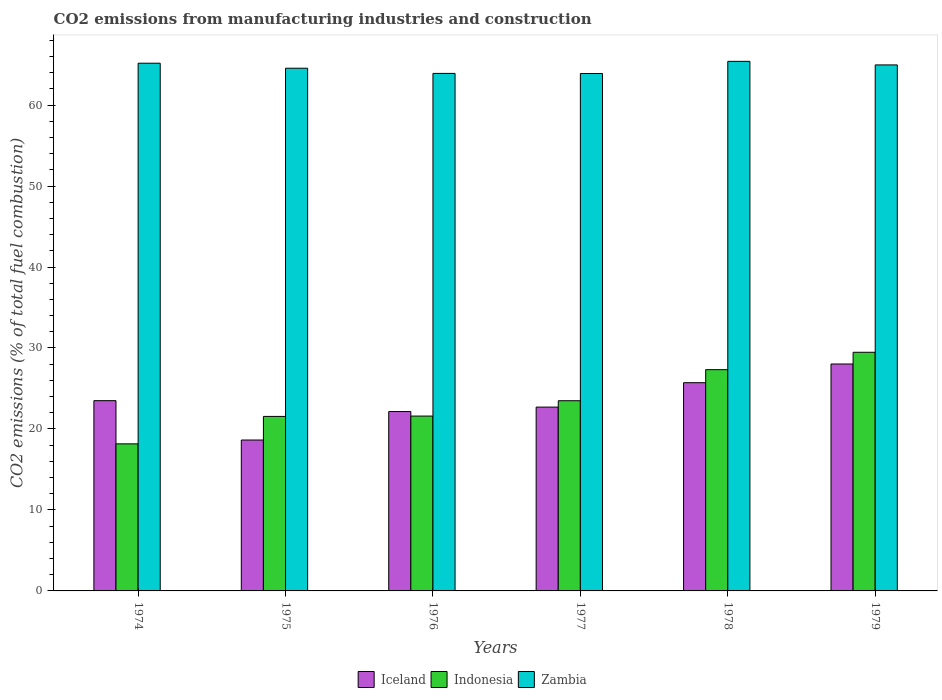How many different coloured bars are there?
Provide a succinct answer. 3. How many groups of bars are there?
Your answer should be very brief. 6. How many bars are there on the 5th tick from the left?
Offer a terse response. 3. How many bars are there on the 1st tick from the right?
Provide a succinct answer. 3. What is the label of the 1st group of bars from the left?
Give a very brief answer. 1974. In how many cases, is the number of bars for a given year not equal to the number of legend labels?
Ensure brevity in your answer.  0. What is the amount of CO2 emitted in Zambia in 1978?
Offer a very short reply. 65.4. Across all years, what is the maximum amount of CO2 emitted in Zambia?
Offer a terse response. 65.4. Across all years, what is the minimum amount of CO2 emitted in Zambia?
Provide a short and direct response. 63.9. In which year was the amount of CO2 emitted in Indonesia maximum?
Keep it short and to the point. 1979. In which year was the amount of CO2 emitted in Iceland minimum?
Your answer should be very brief. 1975. What is the total amount of CO2 emitted in Indonesia in the graph?
Your answer should be very brief. 141.58. What is the difference between the amount of CO2 emitted in Indonesia in 1976 and that in 1979?
Keep it short and to the point. -7.88. What is the difference between the amount of CO2 emitted in Iceland in 1975 and the amount of CO2 emitted in Indonesia in 1974?
Offer a terse response. 0.47. What is the average amount of CO2 emitted in Indonesia per year?
Keep it short and to the point. 23.6. In the year 1974, what is the difference between the amount of CO2 emitted in Zambia and amount of CO2 emitted in Indonesia?
Offer a very short reply. 47. In how many years, is the amount of CO2 emitted in Indonesia greater than 56 %?
Offer a very short reply. 0. What is the ratio of the amount of CO2 emitted in Indonesia in 1975 to that in 1977?
Provide a short and direct response. 0.92. Is the difference between the amount of CO2 emitted in Zambia in 1975 and 1976 greater than the difference between the amount of CO2 emitted in Indonesia in 1975 and 1976?
Your answer should be compact. Yes. What is the difference between the highest and the second highest amount of CO2 emitted in Zambia?
Offer a terse response. 0.23. What is the difference between the highest and the lowest amount of CO2 emitted in Zambia?
Offer a terse response. 1.5. In how many years, is the amount of CO2 emitted in Iceland greater than the average amount of CO2 emitted in Iceland taken over all years?
Offer a terse response. 3. Is the sum of the amount of CO2 emitted in Iceland in 1974 and 1979 greater than the maximum amount of CO2 emitted in Zambia across all years?
Your answer should be compact. No. What does the 1st bar from the left in 1977 represents?
Your answer should be very brief. Iceland. How many years are there in the graph?
Offer a terse response. 6. Are the values on the major ticks of Y-axis written in scientific E-notation?
Provide a short and direct response. No. Does the graph contain any zero values?
Provide a succinct answer. No. How many legend labels are there?
Keep it short and to the point. 3. What is the title of the graph?
Keep it short and to the point. CO2 emissions from manufacturing industries and construction. Does "Chile" appear as one of the legend labels in the graph?
Ensure brevity in your answer.  No. What is the label or title of the X-axis?
Your answer should be very brief. Years. What is the label or title of the Y-axis?
Your response must be concise. CO2 emissions (% of total fuel combustion). What is the CO2 emissions (% of total fuel combustion) of Iceland in 1974?
Your answer should be compact. 23.49. What is the CO2 emissions (% of total fuel combustion) of Indonesia in 1974?
Make the answer very short. 18.16. What is the CO2 emissions (% of total fuel combustion) in Zambia in 1974?
Ensure brevity in your answer.  65.17. What is the CO2 emissions (% of total fuel combustion) of Iceland in 1975?
Your answer should be compact. 18.63. What is the CO2 emissions (% of total fuel combustion) of Indonesia in 1975?
Provide a succinct answer. 21.55. What is the CO2 emissions (% of total fuel combustion) in Zambia in 1975?
Make the answer very short. 64.55. What is the CO2 emissions (% of total fuel combustion) of Iceland in 1976?
Provide a short and direct response. 22.15. What is the CO2 emissions (% of total fuel combustion) of Indonesia in 1976?
Give a very brief answer. 21.59. What is the CO2 emissions (% of total fuel combustion) in Zambia in 1976?
Provide a short and direct response. 63.91. What is the CO2 emissions (% of total fuel combustion) in Iceland in 1977?
Make the answer very short. 22.7. What is the CO2 emissions (% of total fuel combustion) of Indonesia in 1977?
Your answer should be compact. 23.49. What is the CO2 emissions (% of total fuel combustion) of Zambia in 1977?
Make the answer very short. 63.9. What is the CO2 emissions (% of total fuel combustion) in Iceland in 1978?
Provide a short and direct response. 25.71. What is the CO2 emissions (% of total fuel combustion) in Indonesia in 1978?
Your answer should be compact. 27.32. What is the CO2 emissions (% of total fuel combustion) in Zambia in 1978?
Your response must be concise. 65.4. What is the CO2 emissions (% of total fuel combustion) of Iceland in 1979?
Provide a short and direct response. 28.02. What is the CO2 emissions (% of total fuel combustion) of Indonesia in 1979?
Keep it short and to the point. 29.47. What is the CO2 emissions (% of total fuel combustion) in Zambia in 1979?
Provide a short and direct response. 64.95. Across all years, what is the maximum CO2 emissions (% of total fuel combustion) of Iceland?
Your response must be concise. 28.02. Across all years, what is the maximum CO2 emissions (% of total fuel combustion) in Indonesia?
Offer a terse response. 29.47. Across all years, what is the maximum CO2 emissions (% of total fuel combustion) in Zambia?
Your answer should be very brief. 65.4. Across all years, what is the minimum CO2 emissions (% of total fuel combustion) in Iceland?
Offer a terse response. 18.63. Across all years, what is the minimum CO2 emissions (% of total fuel combustion) of Indonesia?
Ensure brevity in your answer.  18.16. Across all years, what is the minimum CO2 emissions (% of total fuel combustion) in Zambia?
Provide a short and direct response. 63.9. What is the total CO2 emissions (% of total fuel combustion) of Iceland in the graph?
Provide a succinct answer. 140.72. What is the total CO2 emissions (% of total fuel combustion) of Indonesia in the graph?
Your response must be concise. 141.58. What is the total CO2 emissions (% of total fuel combustion) in Zambia in the graph?
Provide a succinct answer. 387.87. What is the difference between the CO2 emissions (% of total fuel combustion) in Iceland in 1974 and that in 1975?
Offer a very short reply. 4.86. What is the difference between the CO2 emissions (% of total fuel combustion) in Indonesia in 1974 and that in 1975?
Your answer should be very brief. -3.39. What is the difference between the CO2 emissions (% of total fuel combustion) in Zambia in 1974 and that in 1975?
Give a very brief answer. 0.62. What is the difference between the CO2 emissions (% of total fuel combustion) in Iceland in 1974 and that in 1976?
Your answer should be very brief. 1.34. What is the difference between the CO2 emissions (% of total fuel combustion) of Indonesia in 1974 and that in 1976?
Your answer should be compact. -3.43. What is the difference between the CO2 emissions (% of total fuel combustion) in Zambia in 1974 and that in 1976?
Ensure brevity in your answer.  1.26. What is the difference between the CO2 emissions (% of total fuel combustion) of Iceland in 1974 and that in 1977?
Give a very brief answer. 0.79. What is the difference between the CO2 emissions (% of total fuel combustion) in Indonesia in 1974 and that in 1977?
Give a very brief answer. -5.33. What is the difference between the CO2 emissions (% of total fuel combustion) of Zambia in 1974 and that in 1977?
Make the answer very short. 1.27. What is the difference between the CO2 emissions (% of total fuel combustion) of Iceland in 1974 and that in 1978?
Offer a terse response. -2.22. What is the difference between the CO2 emissions (% of total fuel combustion) of Indonesia in 1974 and that in 1978?
Offer a very short reply. -9.16. What is the difference between the CO2 emissions (% of total fuel combustion) of Zambia in 1974 and that in 1978?
Keep it short and to the point. -0.23. What is the difference between the CO2 emissions (% of total fuel combustion) in Iceland in 1974 and that in 1979?
Keep it short and to the point. -4.53. What is the difference between the CO2 emissions (% of total fuel combustion) of Indonesia in 1974 and that in 1979?
Your answer should be compact. -11.31. What is the difference between the CO2 emissions (% of total fuel combustion) in Zambia in 1974 and that in 1979?
Your answer should be compact. 0.21. What is the difference between the CO2 emissions (% of total fuel combustion) of Iceland in 1975 and that in 1976?
Your answer should be very brief. -3.52. What is the difference between the CO2 emissions (% of total fuel combustion) of Indonesia in 1975 and that in 1976?
Provide a short and direct response. -0.04. What is the difference between the CO2 emissions (% of total fuel combustion) of Zambia in 1975 and that in 1976?
Your response must be concise. 0.64. What is the difference between the CO2 emissions (% of total fuel combustion) of Iceland in 1975 and that in 1977?
Provide a succinct answer. -4.07. What is the difference between the CO2 emissions (% of total fuel combustion) of Indonesia in 1975 and that in 1977?
Ensure brevity in your answer.  -1.94. What is the difference between the CO2 emissions (% of total fuel combustion) of Zambia in 1975 and that in 1977?
Offer a very short reply. 0.65. What is the difference between the CO2 emissions (% of total fuel combustion) in Iceland in 1975 and that in 1978?
Give a very brief answer. -7.08. What is the difference between the CO2 emissions (% of total fuel combustion) of Indonesia in 1975 and that in 1978?
Give a very brief answer. -5.77. What is the difference between the CO2 emissions (% of total fuel combustion) of Zambia in 1975 and that in 1978?
Ensure brevity in your answer.  -0.85. What is the difference between the CO2 emissions (% of total fuel combustion) of Iceland in 1975 and that in 1979?
Ensure brevity in your answer.  -9.39. What is the difference between the CO2 emissions (% of total fuel combustion) in Indonesia in 1975 and that in 1979?
Keep it short and to the point. -7.92. What is the difference between the CO2 emissions (% of total fuel combustion) in Zambia in 1975 and that in 1979?
Make the answer very short. -0.41. What is the difference between the CO2 emissions (% of total fuel combustion) of Iceland in 1976 and that in 1977?
Offer a very short reply. -0.55. What is the difference between the CO2 emissions (% of total fuel combustion) of Indonesia in 1976 and that in 1977?
Provide a succinct answer. -1.9. What is the difference between the CO2 emissions (% of total fuel combustion) of Zambia in 1976 and that in 1977?
Offer a terse response. 0.01. What is the difference between the CO2 emissions (% of total fuel combustion) of Iceland in 1976 and that in 1978?
Offer a terse response. -3.56. What is the difference between the CO2 emissions (% of total fuel combustion) in Indonesia in 1976 and that in 1978?
Offer a terse response. -5.73. What is the difference between the CO2 emissions (% of total fuel combustion) in Zambia in 1976 and that in 1978?
Your answer should be very brief. -1.49. What is the difference between the CO2 emissions (% of total fuel combustion) of Iceland in 1976 and that in 1979?
Your answer should be very brief. -5.87. What is the difference between the CO2 emissions (% of total fuel combustion) of Indonesia in 1976 and that in 1979?
Make the answer very short. -7.88. What is the difference between the CO2 emissions (% of total fuel combustion) of Zambia in 1976 and that in 1979?
Offer a very short reply. -1.05. What is the difference between the CO2 emissions (% of total fuel combustion) of Iceland in 1977 and that in 1978?
Offer a very short reply. -3.01. What is the difference between the CO2 emissions (% of total fuel combustion) in Indonesia in 1977 and that in 1978?
Your response must be concise. -3.84. What is the difference between the CO2 emissions (% of total fuel combustion) in Zambia in 1977 and that in 1978?
Offer a very short reply. -1.5. What is the difference between the CO2 emissions (% of total fuel combustion) in Iceland in 1977 and that in 1979?
Offer a terse response. -5.32. What is the difference between the CO2 emissions (% of total fuel combustion) of Indonesia in 1977 and that in 1979?
Your response must be concise. -5.98. What is the difference between the CO2 emissions (% of total fuel combustion) in Zambia in 1977 and that in 1979?
Your response must be concise. -1.06. What is the difference between the CO2 emissions (% of total fuel combustion) of Iceland in 1978 and that in 1979?
Your response must be concise. -2.31. What is the difference between the CO2 emissions (% of total fuel combustion) in Indonesia in 1978 and that in 1979?
Your answer should be compact. -2.15. What is the difference between the CO2 emissions (% of total fuel combustion) in Zambia in 1978 and that in 1979?
Offer a very short reply. 0.44. What is the difference between the CO2 emissions (% of total fuel combustion) in Iceland in 1974 and the CO2 emissions (% of total fuel combustion) in Indonesia in 1975?
Ensure brevity in your answer.  1.95. What is the difference between the CO2 emissions (% of total fuel combustion) of Iceland in 1974 and the CO2 emissions (% of total fuel combustion) of Zambia in 1975?
Provide a succinct answer. -41.05. What is the difference between the CO2 emissions (% of total fuel combustion) in Indonesia in 1974 and the CO2 emissions (% of total fuel combustion) in Zambia in 1975?
Provide a succinct answer. -46.38. What is the difference between the CO2 emissions (% of total fuel combustion) in Iceland in 1974 and the CO2 emissions (% of total fuel combustion) in Indonesia in 1976?
Offer a terse response. 1.9. What is the difference between the CO2 emissions (% of total fuel combustion) of Iceland in 1974 and the CO2 emissions (% of total fuel combustion) of Zambia in 1976?
Offer a very short reply. -40.41. What is the difference between the CO2 emissions (% of total fuel combustion) of Indonesia in 1974 and the CO2 emissions (% of total fuel combustion) of Zambia in 1976?
Your answer should be compact. -45.75. What is the difference between the CO2 emissions (% of total fuel combustion) in Iceland in 1974 and the CO2 emissions (% of total fuel combustion) in Indonesia in 1977?
Provide a short and direct response. 0.01. What is the difference between the CO2 emissions (% of total fuel combustion) in Iceland in 1974 and the CO2 emissions (% of total fuel combustion) in Zambia in 1977?
Your answer should be compact. -40.4. What is the difference between the CO2 emissions (% of total fuel combustion) in Indonesia in 1974 and the CO2 emissions (% of total fuel combustion) in Zambia in 1977?
Keep it short and to the point. -45.73. What is the difference between the CO2 emissions (% of total fuel combustion) of Iceland in 1974 and the CO2 emissions (% of total fuel combustion) of Indonesia in 1978?
Give a very brief answer. -3.83. What is the difference between the CO2 emissions (% of total fuel combustion) in Iceland in 1974 and the CO2 emissions (% of total fuel combustion) in Zambia in 1978?
Give a very brief answer. -41.9. What is the difference between the CO2 emissions (% of total fuel combustion) of Indonesia in 1974 and the CO2 emissions (% of total fuel combustion) of Zambia in 1978?
Offer a very short reply. -47.23. What is the difference between the CO2 emissions (% of total fuel combustion) of Iceland in 1974 and the CO2 emissions (% of total fuel combustion) of Indonesia in 1979?
Ensure brevity in your answer.  -5.98. What is the difference between the CO2 emissions (% of total fuel combustion) of Iceland in 1974 and the CO2 emissions (% of total fuel combustion) of Zambia in 1979?
Give a very brief answer. -41.46. What is the difference between the CO2 emissions (% of total fuel combustion) of Indonesia in 1974 and the CO2 emissions (% of total fuel combustion) of Zambia in 1979?
Offer a very short reply. -46.79. What is the difference between the CO2 emissions (% of total fuel combustion) of Iceland in 1975 and the CO2 emissions (% of total fuel combustion) of Indonesia in 1976?
Provide a short and direct response. -2.96. What is the difference between the CO2 emissions (% of total fuel combustion) in Iceland in 1975 and the CO2 emissions (% of total fuel combustion) in Zambia in 1976?
Give a very brief answer. -45.27. What is the difference between the CO2 emissions (% of total fuel combustion) of Indonesia in 1975 and the CO2 emissions (% of total fuel combustion) of Zambia in 1976?
Provide a succinct answer. -42.36. What is the difference between the CO2 emissions (% of total fuel combustion) in Iceland in 1975 and the CO2 emissions (% of total fuel combustion) in Indonesia in 1977?
Give a very brief answer. -4.85. What is the difference between the CO2 emissions (% of total fuel combustion) in Iceland in 1975 and the CO2 emissions (% of total fuel combustion) in Zambia in 1977?
Offer a terse response. -45.26. What is the difference between the CO2 emissions (% of total fuel combustion) of Indonesia in 1975 and the CO2 emissions (% of total fuel combustion) of Zambia in 1977?
Provide a short and direct response. -42.35. What is the difference between the CO2 emissions (% of total fuel combustion) in Iceland in 1975 and the CO2 emissions (% of total fuel combustion) in Indonesia in 1978?
Your response must be concise. -8.69. What is the difference between the CO2 emissions (% of total fuel combustion) of Iceland in 1975 and the CO2 emissions (% of total fuel combustion) of Zambia in 1978?
Offer a very short reply. -46.76. What is the difference between the CO2 emissions (% of total fuel combustion) in Indonesia in 1975 and the CO2 emissions (% of total fuel combustion) in Zambia in 1978?
Make the answer very short. -43.85. What is the difference between the CO2 emissions (% of total fuel combustion) of Iceland in 1975 and the CO2 emissions (% of total fuel combustion) of Indonesia in 1979?
Your answer should be very brief. -10.84. What is the difference between the CO2 emissions (% of total fuel combustion) of Iceland in 1975 and the CO2 emissions (% of total fuel combustion) of Zambia in 1979?
Offer a terse response. -46.32. What is the difference between the CO2 emissions (% of total fuel combustion) of Indonesia in 1975 and the CO2 emissions (% of total fuel combustion) of Zambia in 1979?
Offer a very short reply. -43.41. What is the difference between the CO2 emissions (% of total fuel combustion) in Iceland in 1976 and the CO2 emissions (% of total fuel combustion) in Indonesia in 1977?
Provide a short and direct response. -1.34. What is the difference between the CO2 emissions (% of total fuel combustion) of Iceland in 1976 and the CO2 emissions (% of total fuel combustion) of Zambia in 1977?
Provide a short and direct response. -41.74. What is the difference between the CO2 emissions (% of total fuel combustion) of Indonesia in 1976 and the CO2 emissions (% of total fuel combustion) of Zambia in 1977?
Your answer should be very brief. -42.3. What is the difference between the CO2 emissions (% of total fuel combustion) of Iceland in 1976 and the CO2 emissions (% of total fuel combustion) of Indonesia in 1978?
Your answer should be very brief. -5.17. What is the difference between the CO2 emissions (% of total fuel combustion) in Iceland in 1976 and the CO2 emissions (% of total fuel combustion) in Zambia in 1978?
Keep it short and to the point. -43.24. What is the difference between the CO2 emissions (% of total fuel combustion) of Indonesia in 1976 and the CO2 emissions (% of total fuel combustion) of Zambia in 1978?
Provide a succinct answer. -43.8. What is the difference between the CO2 emissions (% of total fuel combustion) in Iceland in 1976 and the CO2 emissions (% of total fuel combustion) in Indonesia in 1979?
Make the answer very short. -7.32. What is the difference between the CO2 emissions (% of total fuel combustion) in Iceland in 1976 and the CO2 emissions (% of total fuel combustion) in Zambia in 1979?
Keep it short and to the point. -42.8. What is the difference between the CO2 emissions (% of total fuel combustion) of Indonesia in 1976 and the CO2 emissions (% of total fuel combustion) of Zambia in 1979?
Provide a succinct answer. -43.36. What is the difference between the CO2 emissions (% of total fuel combustion) of Iceland in 1977 and the CO2 emissions (% of total fuel combustion) of Indonesia in 1978?
Keep it short and to the point. -4.62. What is the difference between the CO2 emissions (% of total fuel combustion) in Iceland in 1977 and the CO2 emissions (% of total fuel combustion) in Zambia in 1978?
Make the answer very short. -42.7. What is the difference between the CO2 emissions (% of total fuel combustion) of Indonesia in 1977 and the CO2 emissions (% of total fuel combustion) of Zambia in 1978?
Make the answer very short. -41.91. What is the difference between the CO2 emissions (% of total fuel combustion) of Iceland in 1977 and the CO2 emissions (% of total fuel combustion) of Indonesia in 1979?
Your answer should be very brief. -6.77. What is the difference between the CO2 emissions (% of total fuel combustion) in Iceland in 1977 and the CO2 emissions (% of total fuel combustion) in Zambia in 1979?
Offer a very short reply. -42.26. What is the difference between the CO2 emissions (% of total fuel combustion) in Indonesia in 1977 and the CO2 emissions (% of total fuel combustion) in Zambia in 1979?
Your answer should be compact. -41.47. What is the difference between the CO2 emissions (% of total fuel combustion) in Iceland in 1978 and the CO2 emissions (% of total fuel combustion) in Indonesia in 1979?
Offer a terse response. -3.76. What is the difference between the CO2 emissions (% of total fuel combustion) of Iceland in 1978 and the CO2 emissions (% of total fuel combustion) of Zambia in 1979?
Offer a very short reply. -39.24. What is the difference between the CO2 emissions (% of total fuel combustion) of Indonesia in 1978 and the CO2 emissions (% of total fuel combustion) of Zambia in 1979?
Provide a short and direct response. -37.63. What is the average CO2 emissions (% of total fuel combustion) of Iceland per year?
Make the answer very short. 23.45. What is the average CO2 emissions (% of total fuel combustion) of Indonesia per year?
Keep it short and to the point. 23.6. What is the average CO2 emissions (% of total fuel combustion) in Zambia per year?
Your answer should be very brief. 64.64. In the year 1974, what is the difference between the CO2 emissions (% of total fuel combustion) of Iceland and CO2 emissions (% of total fuel combustion) of Indonesia?
Make the answer very short. 5.33. In the year 1974, what is the difference between the CO2 emissions (% of total fuel combustion) of Iceland and CO2 emissions (% of total fuel combustion) of Zambia?
Ensure brevity in your answer.  -41.67. In the year 1974, what is the difference between the CO2 emissions (% of total fuel combustion) of Indonesia and CO2 emissions (% of total fuel combustion) of Zambia?
Provide a succinct answer. -47. In the year 1975, what is the difference between the CO2 emissions (% of total fuel combustion) in Iceland and CO2 emissions (% of total fuel combustion) in Indonesia?
Make the answer very short. -2.92. In the year 1975, what is the difference between the CO2 emissions (% of total fuel combustion) in Iceland and CO2 emissions (% of total fuel combustion) in Zambia?
Provide a short and direct response. -45.91. In the year 1975, what is the difference between the CO2 emissions (% of total fuel combustion) in Indonesia and CO2 emissions (% of total fuel combustion) in Zambia?
Your answer should be very brief. -43. In the year 1976, what is the difference between the CO2 emissions (% of total fuel combustion) of Iceland and CO2 emissions (% of total fuel combustion) of Indonesia?
Offer a very short reply. 0.56. In the year 1976, what is the difference between the CO2 emissions (% of total fuel combustion) of Iceland and CO2 emissions (% of total fuel combustion) of Zambia?
Provide a succinct answer. -41.76. In the year 1976, what is the difference between the CO2 emissions (% of total fuel combustion) in Indonesia and CO2 emissions (% of total fuel combustion) in Zambia?
Make the answer very short. -42.32. In the year 1977, what is the difference between the CO2 emissions (% of total fuel combustion) of Iceland and CO2 emissions (% of total fuel combustion) of Indonesia?
Your answer should be compact. -0.79. In the year 1977, what is the difference between the CO2 emissions (% of total fuel combustion) of Iceland and CO2 emissions (% of total fuel combustion) of Zambia?
Your answer should be very brief. -41.2. In the year 1977, what is the difference between the CO2 emissions (% of total fuel combustion) of Indonesia and CO2 emissions (% of total fuel combustion) of Zambia?
Your response must be concise. -40.41. In the year 1978, what is the difference between the CO2 emissions (% of total fuel combustion) in Iceland and CO2 emissions (% of total fuel combustion) in Indonesia?
Make the answer very short. -1.61. In the year 1978, what is the difference between the CO2 emissions (% of total fuel combustion) of Iceland and CO2 emissions (% of total fuel combustion) of Zambia?
Offer a terse response. -39.68. In the year 1978, what is the difference between the CO2 emissions (% of total fuel combustion) of Indonesia and CO2 emissions (% of total fuel combustion) of Zambia?
Ensure brevity in your answer.  -38.07. In the year 1979, what is the difference between the CO2 emissions (% of total fuel combustion) in Iceland and CO2 emissions (% of total fuel combustion) in Indonesia?
Offer a terse response. -1.45. In the year 1979, what is the difference between the CO2 emissions (% of total fuel combustion) of Iceland and CO2 emissions (% of total fuel combustion) of Zambia?
Your answer should be compact. -36.93. In the year 1979, what is the difference between the CO2 emissions (% of total fuel combustion) in Indonesia and CO2 emissions (% of total fuel combustion) in Zambia?
Your answer should be very brief. -35.48. What is the ratio of the CO2 emissions (% of total fuel combustion) of Iceland in 1974 to that in 1975?
Provide a succinct answer. 1.26. What is the ratio of the CO2 emissions (% of total fuel combustion) of Indonesia in 1974 to that in 1975?
Give a very brief answer. 0.84. What is the ratio of the CO2 emissions (% of total fuel combustion) in Zambia in 1974 to that in 1975?
Your answer should be compact. 1.01. What is the ratio of the CO2 emissions (% of total fuel combustion) in Iceland in 1974 to that in 1976?
Keep it short and to the point. 1.06. What is the ratio of the CO2 emissions (% of total fuel combustion) in Indonesia in 1974 to that in 1976?
Offer a terse response. 0.84. What is the ratio of the CO2 emissions (% of total fuel combustion) of Zambia in 1974 to that in 1976?
Your answer should be very brief. 1.02. What is the ratio of the CO2 emissions (% of total fuel combustion) in Iceland in 1974 to that in 1977?
Ensure brevity in your answer.  1.03. What is the ratio of the CO2 emissions (% of total fuel combustion) of Indonesia in 1974 to that in 1977?
Your answer should be very brief. 0.77. What is the ratio of the CO2 emissions (% of total fuel combustion) of Zambia in 1974 to that in 1977?
Offer a terse response. 1.02. What is the ratio of the CO2 emissions (% of total fuel combustion) in Iceland in 1974 to that in 1978?
Make the answer very short. 0.91. What is the ratio of the CO2 emissions (% of total fuel combustion) in Indonesia in 1974 to that in 1978?
Provide a short and direct response. 0.66. What is the ratio of the CO2 emissions (% of total fuel combustion) of Iceland in 1974 to that in 1979?
Offer a very short reply. 0.84. What is the ratio of the CO2 emissions (% of total fuel combustion) in Indonesia in 1974 to that in 1979?
Offer a terse response. 0.62. What is the ratio of the CO2 emissions (% of total fuel combustion) of Iceland in 1975 to that in 1976?
Keep it short and to the point. 0.84. What is the ratio of the CO2 emissions (% of total fuel combustion) in Zambia in 1975 to that in 1976?
Offer a very short reply. 1.01. What is the ratio of the CO2 emissions (% of total fuel combustion) of Iceland in 1975 to that in 1977?
Make the answer very short. 0.82. What is the ratio of the CO2 emissions (% of total fuel combustion) of Indonesia in 1975 to that in 1977?
Make the answer very short. 0.92. What is the ratio of the CO2 emissions (% of total fuel combustion) in Zambia in 1975 to that in 1977?
Make the answer very short. 1.01. What is the ratio of the CO2 emissions (% of total fuel combustion) of Iceland in 1975 to that in 1978?
Offer a very short reply. 0.72. What is the ratio of the CO2 emissions (% of total fuel combustion) in Indonesia in 1975 to that in 1978?
Your answer should be compact. 0.79. What is the ratio of the CO2 emissions (% of total fuel combustion) of Zambia in 1975 to that in 1978?
Your answer should be very brief. 0.99. What is the ratio of the CO2 emissions (% of total fuel combustion) of Iceland in 1975 to that in 1979?
Keep it short and to the point. 0.67. What is the ratio of the CO2 emissions (% of total fuel combustion) of Indonesia in 1975 to that in 1979?
Your answer should be very brief. 0.73. What is the ratio of the CO2 emissions (% of total fuel combustion) in Zambia in 1975 to that in 1979?
Your answer should be very brief. 0.99. What is the ratio of the CO2 emissions (% of total fuel combustion) in Iceland in 1976 to that in 1977?
Offer a terse response. 0.98. What is the ratio of the CO2 emissions (% of total fuel combustion) in Indonesia in 1976 to that in 1977?
Provide a short and direct response. 0.92. What is the ratio of the CO2 emissions (% of total fuel combustion) of Iceland in 1976 to that in 1978?
Offer a very short reply. 0.86. What is the ratio of the CO2 emissions (% of total fuel combustion) in Indonesia in 1976 to that in 1978?
Your response must be concise. 0.79. What is the ratio of the CO2 emissions (% of total fuel combustion) of Zambia in 1976 to that in 1978?
Offer a terse response. 0.98. What is the ratio of the CO2 emissions (% of total fuel combustion) in Iceland in 1976 to that in 1979?
Your answer should be very brief. 0.79. What is the ratio of the CO2 emissions (% of total fuel combustion) in Indonesia in 1976 to that in 1979?
Keep it short and to the point. 0.73. What is the ratio of the CO2 emissions (% of total fuel combustion) of Zambia in 1976 to that in 1979?
Offer a very short reply. 0.98. What is the ratio of the CO2 emissions (% of total fuel combustion) in Iceland in 1977 to that in 1978?
Ensure brevity in your answer.  0.88. What is the ratio of the CO2 emissions (% of total fuel combustion) in Indonesia in 1977 to that in 1978?
Your response must be concise. 0.86. What is the ratio of the CO2 emissions (% of total fuel combustion) of Zambia in 1977 to that in 1978?
Offer a terse response. 0.98. What is the ratio of the CO2 emissions (% of total fuel combustion) of Iceland in 1977 to that in 1979?
Your answer should be very brief. 0.81. What is the ratio of the CO2 emissions (% of total fuel combustion) in Indonesia in 1977 to that in 1979?
Give a very brief answer. 0.8. What is the ratio of the CO2 emissions (% of total fuel combustion) of Zambia in 1977 to that in 1979?
Your answer should be compact. 0.98. What is the ratio of the CO2 emissions (% of total fuel combustion) in Iceland in 1978 to that in 1979?
Offer a terse response. 0.92. What is the ratio of the CO2 emissions (% of total fuel combustion) in Indonesia in 1978 to that in 1979?
Offer a terse response. 0.93. What is the ratio of the CO2 emissions (% of total fuel combustion) of Zambia in 1978 to that in 1979?
Ensure brevity in your answer.  1.01. What is the difference between the highest and the second highest CO2 emissions (% of total fuel combustion) of Iceland?
Make the answer very short. 2.31. What is the difference between the highest and the second highest CO2 emissions (% of total fuel combustion) in Indonesia?
Keep it short and to the point. 2.15. What is the difference between the highest and the second highest CO2 emissions (% of total fuel combustion) of Zambia?
Offer a terse response. 0.23. What is the difference between the highest and the lowest CO2 emissions (% of total fuel combustion) of Iceland?
Keep it short and to the point. 9.39. What is the difference between the highest and the lowest CO2 emissions (% of total fuel combustion) in Indonesia?
Offer a very short reply. 11.31. What is the difference between the highest and the lowest CO2 emissions (% of total fuel combustion) of Zambia?
Provide a succinct answer. 1.5. 